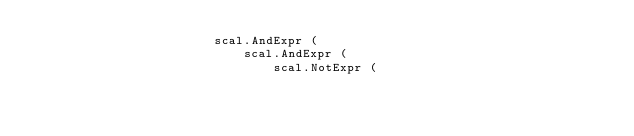Convert code to text. <code><loc_0><loc_0><loc_500><loc_500><_Python_>                        scal.AndExpr ( 
                            scal.AndExpr (
                                scal.NotExpr ( </code> 